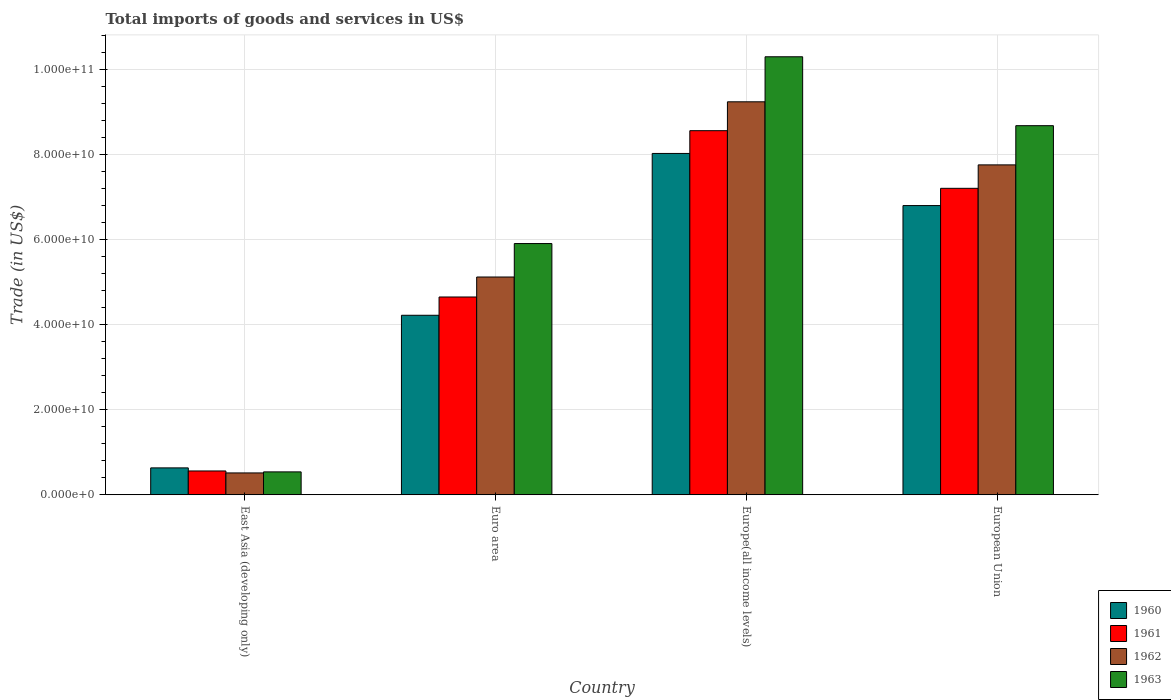Are the number of bars per tick equal to the number of legend labels?
Make the answer very short. Yes. What is the label of the 1st group of bars from the left?
Your answer should be very brief. East Asia (developing only). What is the total imports of goods and services in 1963 in Europe(all income levels)?
Offer a terse response. 1.03e+11. Across all countries, what is the maximum total imports of goods and services in 1962?
Ensure brevity in your answer.  9.24e+1. Across all countries, what is the minimum total imports of goods and services in 1960?
Your answer should be very brief. 6.33e+09. In which country was the total imports of goods and services in 1960 maximum?
Provide a short and direct response. Europe(all income levels). In which country was the total imports of goods and services in 1962 minimum?
Offer a very short reply. East Asia (developing only). What is the total total imports of goods and services in 1960 in the graph?
Ensure brevity in your answer.  1.97e+11. What is the difference between the total imports of goods and services in 1961 in Europe(all income levels) and that in European Union?
Provide a short and direct response. 1.36e+1. What is the difference between the total imports of goods and services in 1962 in European Union and the total imports of goods and services in 1960 in Euro area?
Your response must be concise. 3.54e+1. What is the average total imports of goods and services in 1963 per country?
Keep it short and to the point. 6.36e+1. What is the difference between the total imports of goods and services of/in 1962 and total imports of goods and services of/in 1963 in Euro area?
Provide a short and direct response. -7.86e+09. What is the ratio of the total imports of goods and services in 1962 in East Asia (developing only) to that in Europe(all income levels)?
Give a very brief answer. 0.06. Is the difference between the total imports of goods and services in 1962 in East Asia (developing only) and European Union greater than the difference between the total imports of goods and services in 1963 in East Asia (developing only) and European Union?
Your answer should be very brief. Yes. What is the difference between the highest and the second highest total imports of goods and services in 1962?
Offer a very short reply. -4.12e+1. What is the difference between the highest and the lowest total imports of goods and services in 1963?
Your answer should be compact. 9.76e+1. In how many countries, is the total imports of goods and services in 1962 greater than the average total imports of goods and services in 1962 taken over all countries?
Keep it short and to the point. 2. Is the sum of the total imports of goods and services in 1961 in Euro area and European Union greater than the maximum total imports of goods and services in 1962 across all countries?
Ensure brevity in your answer.  Yes. What does the 4th bar from the left in Euro area represents?
Offer a very short reply. 1963. How many bars are there?
Ensure brevity in your answer.  16. How many countries are there in the graph?
Make the answer very short. 4. Are the values on the major ticks of Y-axis written in scientific E-notation?
Give a very brief answer. Yes. How are the legend labels stacked?
Offer a terse response. Vertical. What is the title of the graph?
Offer a very short reply. Total imports of goods and services in US$. Does "1981" appear as one of the legend labels in the graph?
Ensure brevity in your answer.  No. What is the label or title of the Y-axis?
Your answer should be very brief. Trade (in US$). What is the Trade (in US$) in 1960 in East Asia (developing only)?
Offer a very short reply. 6.33e+09. What is the Trade (in US$) in 1961 in East Asia (developing only)?
Offer a very short reply. 5.60e+09. What is the Trade (in US$) of 1962 in East Asia (developing only)?
Offer a very short reply. 5.14e+09. What is the Trade (in US$) of 1963 in East Asia (developing only)?
Offer a terse response. 5.39e+09. What is the Trade (in US$) of 1960 in Euro area?
Provide a short and direct response. 4.22e+1. What is the Trade (in US$) in 1961 in Euro area?
Ensure brevity in your answer.  4.65e+1. What is the Trade (in US$) in 1962 in Euro area?
Offer a terse response. 5.12e+1. What is the Trade (in US$) in 1963 in Euro area?
Offer a terse response. 5.91e+1. What is the Trade (in US$) of 1960 in Europe(all income levels)?
Offer a very short reply. 8.03e+1. What is the Trade (in US$) of 1961 in Europe(all income levels)?
Ensure brevity in your answer.  8.56e+1. What is the Trade (in US$) in 1962 in Europe(all income levels)?
Your response must be concise. 9.24e+1. What is the Trade (in US$) in 1963 in Europe(all income levels)?
Provide a short and direct response. 1.03e+11. What is the Trade (in US$) in 1960 in European Union?
Offer a very short reply. 6.80e+1. What is the Trade (in US$) of 1961 in European Union?
Your response must be concise. 7.21e+1. What is the Trade (in US$) in 1962 in European Union?
Keep it short and to the point. 7.76e+1. What is the Trade (in US$) in 1963 in European Union?
Keep it short and to the point. 8.68e+1. Across all countries, what is the maximum Trade (in US$) in 1960?
Ensure brevity in your answer.  8.03e+1. Across all countries, what is the maximum Trade (in US$) in 1961?
Ensure brevity in your answer.  8.56e+1. Across all countries, what is the maximum Trade (in US$) in 1962?
Your answer should be compact. 9.24e+1. Across all countries, what is the maximum Trade (in US$) of 1963?
Offer a terse response. 1.03e+11. Across all countries, what is the minimum Trade (in US$) of 1960?
Provide a short and direct response. 6.33e+09. Across all countries, what is the minimum Trade (in US$) in 1961?
Keep it short and to the point. 5.60e+09. Across all countries, what is the minimum Trade (in US$) of 1962?
Offer a very short reply. 5.14e+09. Across all countries, what is the minimum Trade (in US$) in 1963?
Ensure brevity in your answer.  5.39e+09. What is the total Trade (in US$) in 1960 in the graph?
Provide a succinct answer. 1.97e+11. What is the total Trade (in US$) in 1961 in the graph?
Provide a short and direct response. 2.10e+11. What is the total Trade (in US$) of 1962 in the graph?
Your response must be concise. 2.26e+11. What is the total Trade (in US$) in 1963 in the graph?
Your answer should be very brief. 2.54e+11. What is the difference between the Trade (in US$) in 1960 in East Asia (developing only) and that in Euro area?
Ensure brevity in your answer.  -3.59e+1. What is the difference between the Trade (in US$) in 1961 in East Asia (developing only) and that in Euro area?
Your answer should be very brief. -4.09e+1. What is the difference between the Trade (in US$) of 1962 in East Asia (developing only) and that in Euro area?
Give a very brief answer. -4.61e+1. What is the difference between the Trade (in US$) of 1963 in East Asia (developing only) and that in Euro area?
Your answer should be compact. -5.37e+1. What is the difference between the Trade (in US$) of 1960 in East Asia (developing only) and that in Europe(all income levels)?
Your answer should be compact. -7.39e+1. What is the difference between the Trade (in US$) of 1961 in East Asia (developing only) and that in Europe(all income levels)?
Give a very brief answer. -8.00e+1. What is the difference between the Trade (in US$) of 1962 in East Asia (developing only) and that in Europe(all income levels)?
Offer a terse response. -8.73e+1. What is the difference between the Trade (in US$) of 1963 in East Asia (developing only) and that in Europe(all income levels)?
Your answer should be compact. -9.76e+1. What is the difference between the Trade (in US$) of 1960 in East Asia (developing only) and that in European Union?
Offer a terse response. -6.17e+1. What is the difference between the Trade (in US$) of 1961 in East Asia (developing only) and that in European Union?
Your answer should be compact. -6.65e+1. What is the difference between the Trade (in US$) of 1962 in East Asia (developing only) and that in European Union?
Provide a succinct answer. -7.24e+1. What is the difference between the Trade (in US$) in 1963 in East Asia (developing only) and that in European Union?
Ensure brevity in your answer.  -8.14e+1. What is the difference between the Trade (in US$) of 1960 in Euro area and that in Europe(all income levels)?
Make the answer very short. -3.80e+1. What is the difference between the Trade (in US$) of 1961 in Euro area and that in Europe(all income levels)?
Give a very brief answer. -3.91e+1. What is the difference between the Trade (in US$) of 1962 in Euro area and that in Europe(all income levels)?
Keep it short and to the point. -4.12e+1. What is the difference between the Trade (in US$) of 1963 in Euro area and that in Europe(all income levels)?
Give a very brief answer. -4.39e+1. What is the difference between the Trade (in US$) in 1960 in Euro area and that in European Union?
Your response must be concise. -2.58e+1. What is the difference between the Trade (in US$) of 1961 in Euro area and that in European Union?
Offer a very short reply. -2.56e+1. What is the difference between the Trade (in US$) in 1962 in Euro area and that in European Union?
Your answer should be very brief. -2.64e+1. What is the difference between the Trade (in US$) in 1963 in Euro area and that in European Union?
Provide a short and direct response. -2.77e+1. What is the difference between the Trade (in US$) of 1960 in Europe(all income levels) and that in European Union?
Your response must be concise. 1.23e+1. What is the difference between the Trade (in US$) of 1961 in Europe(all income levels) and that in European Union?
Give a very brief answer. 1.36e+1. What is the difference between the Trade (in US$) in 1962 in Europe(all income levels) and that in European Union?
Your answer should be compact. 1.48e+1. What is the difference between the Trade (in US$) in 1963 in Europe(all income levels) and that in European Union?
Provide a succinct answer. 1.62e+1. What is the difference between the Trade (in US$) of 1960 in East Asia (developing only) and the Trade (in US$) of 1961 in Euro area?
Your response must be concise. -4.02e+1. What is the difference between the Trade (in US$) of 1960 in East Asia (developing only) and the Trade (in US$) of 1962 in Euro area?
Provide a succinct answer. -4.49e+1. What is the difference between the Trade (in US$) of 1960 in East Asia (developing only) and the Trade (in US$) of 1963 in Euro area?
Offer a very short reply. -5.27e+1. What is the difference between the Trade (in US$) in 1961 in East Asia (developing only) and the Trade (in US$) in 1962 in Euro area?
Provide a succinct answer. -4.56e+1. What is the difference between the Trade (in US$) in 1961 in East Asia (developing only) and the Trade (in US$) in 1963 in Euro area?
Provide a succinct answer. -5.35e+1. What is the difference between the Trade (in US$) in 1962 in East Asia (developing only) and the Trade (in US$) in 1963 in Euro area?
Give a very brief answer. -5.39e+1. What is the difference between the Trade (in US$) of 1960 in East Asia (developing only) and the Trade (in US$) of 1961 in Europe(all income levels)?
Keep it short and to the point. -7.93e+1. What is the difference between the Trade (in US$) in 1960 in East Asia (developing only) and the Trade (in US$) in 1962 in Europe(all income levels)?
Make the answer very short. -8.61e+1. What is the difference between the Trade (in US$) of 1960 in East Asia (developing only) and the Trade (in US$) of 1963 in Europe(all income levels)?
Provide a short and direct response. -9.67e+1. What is the difference between the Trade (in US$) in 1961 in East Asia (developing only) and the Trade (in US$) in 1962 in Europe(all income levels)?
Your answer should be very brief. -8.68e+1. What is the difference between the Trade (in US$) of 1961 in East Asia (developing only) and the Trade (in US$) of 1963 in Europe(all income levels)?
Offer a terse response. -9.74e+1. What is the difference between the Trade (in US$) of 1962 in East Asia (developing only) and the Trade (in US$) of 1963 in Europe(all income levels)?
Give a very brief answer. -9.79e+1. What is the difference between the Trade (in US$) of 1960 in East Asia (developing only) and the Trade (in US$) of 1961 in European Union?
Your answer should be very brief. -6.57e+1. What is the difference between the Trade (in US$) in 1960 in East Asia (developing only) and the Trade (in US$) in 1962 in European Union?
Offer a terse response. -7.12e+1. What is the difference between the Trade (in US$) of 1960 in East Asia (developing only) and the Trade (in US$) of 1963 in European Union?
Ensure brevity in your answer.  -8.05e+1. What is the difference between the Trade (in US$) in 1961 in East Asia (developing only) and the Trade (in US$) in 1962 in European Union?
Your answer should be compact. -7.20e+1. What is the difference between the Trade (in US$) in 1961 in East Asia (developing only) and the Trade (in US$) in 1963 in European Union?
Offer a very short reply. -8.12e+1. What is the difference between the Trade (in US$) of 1962 in East Asia (developing only) and the Trade (in US$) of 1963 in European Union?
Give a very brief answer. -8.17e+1. What is the difference between the Trade (in US$) in 1960 in Euro area and the Trade (in US$) in 1961 in Europe(all income levels)?
Ensure brevity in your answer.  -4.34e+1. What is the difference between the Trade (in US$) in 1960 in Euro area and the Trade (in US$) in 1962 in Europe(all income levels)?
Your answer should be very brief. -5.02e+1. What is the difference between the Trade (in US$) of 1960 in Euro area and the Trade (in US$) of 1963 in Europe(all income levels)?
Make the answer very short. -6.08e+1. What is the difference between the Trade (in US$) of 1961 in Euro area and the Trade (in US$) of 1962 in Europe(all income levels)?
Offer a terse response. -4.59e+1. What is the difference between the Trade (in US$) of 1961 in Euro area and the Trade (in US$) of 1963 in Europe(all income levels)?
Your answer should be compact. -5.65e+1. What is the difference between the Trade (in US$) of 1962 in Euro area and the Trade (in US$) of 1963 in Europe(all income levels)?
Ensure brevity in your answer.  -5.18e+1. What is the difference between the Trade (in US$) of 1960 in Euro area and the Trade (in US$) of 1961 in European Union?
Your answer should be very brief. -2.98e+1. What is the difference between the Trade (in US$) in 1960 in Euro area and the Trade (in US$) in 1962 in European Union?
Ensure brevity in your answer.  -3.54e+1. What is the difference between the Trade (in US$) of 1960 in Euro area and the Trade (in US$) of 1963 in European Union?
Offer a very short reply. -4.46e+1. What is the difference between the Trade (in US$) in 1961 in Euro area and the Trade (in US$) in 1962 in European Union?
Your answer should be compact. -3.11e+1. What is the difference between the Trade (in US$) in 1961 in Euro area and the Trade (in US$) in 1963 in European Union?
Your answer should be very brief. -4.03e+1. What is the difference between the Trade (in US$) in 1962 in Euro area and the Trade (in US$) in 1963 in European Union?
Make the answer very short. -3.56e+1. What is the difference between the Trade (in US$) in 1960 in Europe(all income levels) and the Trade (in US$) in 1961 in European Union?
Your answer should be compact. 8.20e+09. What is the difference between the Trade (in US$) in 1960 in Europe(all income levels) and the Trade (in US$) in 1962 in European Union?
Make the answer very short. 2.69e+09. What is the difference between the Trade (in US$) of 1960 in Europe(all income levels) and the Trade (in US$) of 1963 in European Union?
Give a very brief answer. -6.53e+09. What is the difference between the Trade (in US$) in 1961 in Europe(all income levels) and the Trade (in US$) in 1962 in European Union?
Offer a very short reply. 8.04e+09. What is the difference between the Trade (in US$) of 1961 in Europe(all income levels) and the Trade (in US$) of 1963 in European Union?
Provide a short and direct response. -1.18e+09. What is the difference between the Trade (in US$) of 1962 in Europe(all income levels) and the Trade (in US$) of 1963 in European Union?
Ensure brevity in your answer.  5.61e+09. What is the average Trade (in US$) of 1960 per country?
Ensure brevity in your answer.  4.92e+1. What is the average Trade (in US$) in 1961 per country?
Offer a terse response. 5.24e+1. What is the average Trade (in US$) in 1962 per country?
Your answer should be compact. 5.66e+1. What is the average Trade (in US$) of 1963 per country?
Provide a short and direct response. 6.36e+1. What is the difference between the Trade (in US$) of 1960 and Trade (in US$) of 1961 in East Asia (developing only)?
Ensure brevity in your answer.  7.24e+08. What is the difference between the Trade (in US$) of 1960 and Trade (in US$) of 1962 in East Asia (developing only)?
Your response must be concise. 1.19e+09. What is the difference between the Trade (in US$) of 1960 and Trade (in US$) of 1963 in East Asia (developing only)?
Provide a succinct answer. 9.42e+08. What is the difference between the Trade (in US$) in 1961 and Trade (in US$) in 1962 in East Asia (developing only)?
Give a very brief answer. 4.63e+08. What is the difference between the Trade (in US$) of 1961 and Trade (in US$) of 1963 in East Asia (developing only)?
Your answer should be very brief. 2.18e+08. What is the difference between the Trade (in US$) in 1962 and Trade (in US$) in 1963 in East Asia (developing only)?
Provide a short and direct response. -2.45e+08. What is the difference between the Trade (in US$) in 1960 and Trade (in US$) in 1961 in Euro area?
Offer a terse response. -4.30e+09. What is the difference between the Trade (in US$) of 1960 and Trade (in US$) of 1962 in Euro area?
Provide a succinct answer. -9.00e+09. What is the difference between the Trade (in US$) in 1960 and Trade (in US$) in 1963 in Euro area?
Offer a very short reply. -1.69e+1. What is the difference between the Trade (in US$) of 1961 and Trade (in US$) of 1962 in Euro area?
Your answer should be compact. -4.70e+09. What is the difference between the Trade (in US$) in 1961 and Trade (in US$) in 1963 in Euro area?
Give a very brief answer. -1.26e+1. What is the difference between the Trade (in US$) of 1962 and Trade (in US$) of 1963 in Euro area?
Your answer should be very brief. -7.86e+09. What is the difference between the Trade (in US$) of 1960 and Trade (in US$) of 1961 in Europe(all income levels)?
Ensure brevity in your answer.  -5.35e+09. What is the difference between the Trade (in US$) of 1960 and Trade (in US$) of 1962 in Europe(all income levels)?
Provide a short and direct response. -1.21e+1. What is the difference between the Trade (in US$) of 1960 and Trade (in US$) of 1963 in Europe(all income levels)?
Your answer should be very brief. -2.27e+1. What is the difference between the Trade (in US$) of 1961 and Trade (in US$) of 1962 in Europe(all income levels)?
Provide a succinct answer. -6.79e+09. What is the difference between the Trade (in US$) in 1961 and Trade (in US$) in 1963 in Europe(all income levels)?
Your answer should be compact. -1.74e+1. What is the difference between the Trade (in US$) in 1962 and Trade (in US$) in 1963 in Europe(all income levels)?
Provide a succinct answer. -1.06e+1. What is the difference between the Trade (in US$) in 1960 and Trade (in US$) in 1961 in European Union?
Ensure brevity in your answer.  -4.05e+09. What is the difference between the Trade (in US$) of 1960 and Trade (in US$) of 1962 in European Union?
Your answer should be very brief. -9.57e+09. What is the difference between the Trade (in US$) of 1960 and Trade (in US$) of 1963 in European Union?
Your answer should be very brief. -1.88e+1. What is the difference between the Trade (in US$) of 1961 and Trade (in US$) of 1962 in European Union?
Provide a short and direct response. -5.51e+09. What is the difference between the Trade (in US$) of 1961 and Trade (in US$) of 1963 in European Union?
Your response must be concise. -1.47e+1. What is the difference between the Trade (in US$) of 1962 and Trade (in US$) of 1963 in European Union?
Make the answer very short. -9.22e+09. What is the ratio of the Trade (in US$) in 1960 in East Asia (developing only) to that in Euro area?
Make the answer very short. 0.15. What is the ratio of the Trade (in US$) in 1961 in East Asia (developing only) to that in Euro area?
Offer a terse response. 0.12. What is the ratio of the Trade (in US$) in 1962 in East Asia (developing only) to that in Euro area?
Ensure brevity in your answer.  0.1. What is the ratio of the Trade (in US$) in 1963 in East Asia (developing only) to that in Euro area?
Provide a succinct answer. 0.09. What is the ratio of the Trade (in US$) of 1960 in East Asia (developing only) to that in Europe(all income levels)?
Ensure brevity in your answer.  0.08. What is the ratio of the Trade (in US$) of 1961 in East Asia (developing only) to that in Europe(all income levels)?
Your response must be concise. 0.07. What is the ratio of the Trade (in US$) of 1962 in East Asia (developing only) to that in Europe(all income levels)?
Your answer should be compact. 0.06. What is the ratio of the Trade (in US$) in 1963 in East Asia (developing only) to that in Europe(all income levels)?
Make the answer very short. 0.05. What is the ratio of the Trade (in US$) in 1960 in East Asia (developing only) to that in European Union?
Make the answer very short. 0.09. What is the ratio of the Trade (in US$) in 1961 in East Asia (developing only) to that in European Union?
Ensure brevity in your answer.  0.08. What is the ratio of the Trade (in US$) in 1962 in East Asia (developing only) to that in European Union?
Ensure brevity in your answer.  0.07. What is the ratio of the Trade (in US$) of 1963 in East Asia (developing only) to that in European Union?
Provide a short and direct response. 0.06. What is the ratio of the Trade (in US$) of 1960 in Euro area to that in Europe(all income levels)?
Provide a short and direct response. 0.53. What is the ratio of the Trade (in US$) in 1961 in Euro area to that in Europe(all income levels)?
Offer a terse response. 0.54. What is the ratio of the Trade (in US$) in 1962 in Euro area to that in Europe(all income levels)?
Your answer should be compact. 0.55. What is the ratio of the Trade (in US$) in 1963 in Euro area to that in Europe(all income levels)?
Give a very brief answer. 0.57. What is the ratio of the Trade (in US$) in 1960 in Euro area to that in European Union?
Offer a terse response. 0.62. What is the ratio of the Trade (in US$) in 1961 in Euro area to that in European Union?
Ensure brevity in your answer.  0.65. What is the ratio of the Trade (in US$) of 1962 in Euro area to that in European Union?
Your answer should be very brief. 0.66. What is the ratio of the Trade (in US$) in 1963 in Euro area to that in European Union?
Offer a terse response. 0.68. What is the ratio of the Trade (in US$) in 1960 in Europe(all income levels) to that in European Union?
Give a very brief answer. 1.18. What is the ratio of the Trade (in US$) of 1961 in Europe(all income levels) to that in European Union?
Your answer should be compact. 1.19. What is the ratio of the Trade (in US$) of 1962 in Europe(all income levels) to that in European Union?
Offer a very short reply. 1.19. What is the ratio of the Trade (in US$) in 1963 in Europe(all income levels) to that in European Union?
Offer a terse response. 1.19. What is the difference between the highest and the second highest Trade (in US$) of 1960?
Offer a terse response. 1.23e+1. What is the difference between the highest and the second highest Trade (in US$) in 1961?
Your answer should be compact. 1.36e+1. What is the difference between the highest and the second highest Trade (in US$) of 1962?
Make the answer very short. 1.48e+1. What is the difference between the highest and the second highest Trade (in US$) in 1963?
Offer a very short reply. 1.62e+1. What is the difference between the highest and the lowest Trade (in US$) of 1960?
Ensure brevity in your answer.  7.39e+1. What is the difference between the highest and the lowest Trade (in US$) of 1961?
Your response must be concise. 8.00e+1. What is the difference between the highest and the lowest Trade (in US$) in 1962?
Your response must be concise. 8.73e+1. What is the difference between the highest and the lowest Trade (in US$) in 1963?
Keep it short and to the point. 9.76e+1. 